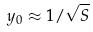<formula> <loc_0><loc_0><loc_500><loc_500>y _ { 0 } \approx 1 / \sqrt { S }</formula> 